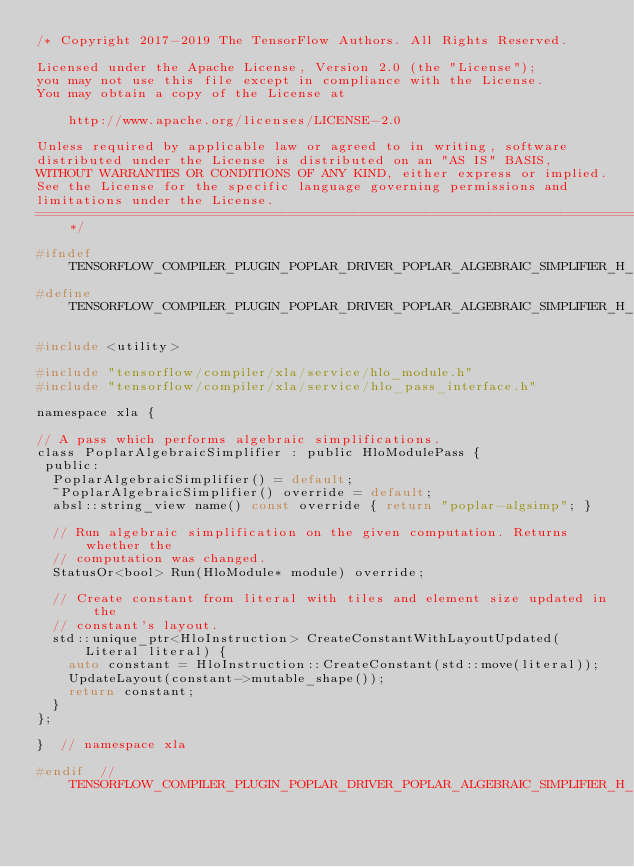<code> <loc_0><loc_0><loc_500><loc_500><_C_>/* Copyright 2017-2019 The TensorFlow Authors. All Rights Reserved.

Licensed under the Apache License, Version 2.0 (the "License");
you may not use this file except in compliance with the License.
You may obtain a copy of the License at

    http://www.apache.org/licenses/LICENSE-2.0

Unless required by applicable law or agreed to in writing, software
distributed under the License is distributed on an "AS IS" BASIS,
WITHOUT WARRANTIES OR CONDITIONS OF ANY KIND, either express or implied.
See the License for the specific language governing permissions and
limitations under the License.
==============================================================================*/

#ifndef TENSORFLOW_COMPILER_PLUGIN_POPLAR_DRIVER_POPLAR_ALGEBRAIC_SIMPLIFIER_H_
#define TENSORFLOW_COMPILER_PLUGIN_POPLAR_DRIVER_POPLAR_ALGEBRAIC_SIMPLIFIER_H_

#include <utility>

#include "tensorflow/compiler/xla/service/hlo_module.h"
#include "tensorflow/compiler/xla/service/hlo_pass_interface.h"

namespace xla {

// A pass which performs algebraic simplifications.
class PoplarAlgebraicSimplifier : public HloModulePass {
 public:
  PoplarAlgebraicSimplifier() = default;
  ~PoplarAlgebraicSimplifier() override = default;
  absl::string_view name() const override { return "poplar-algsimp"; }

  // Run algebraic simplification on the given computation. Returns whether the
  // computation was changed.
  StatusOr<bool> Run(HloModule* module) override;

  // Create constant from literal with tiles and element size updated in the
  // constant's layout.
  std::unique_ptr<HloInstruction> CreateConstantWithLayoutUpdated(
      Literal literal) {
    auto constant = HloInstruction::CreateConstant(std::move(literal));
    UpdateLayout(constant->mutable_shape());
    return constant;
  }
};

}  // namespace xla

#endif  // TENSORFLOW_COMPILER_PLUGIN_POPLAR_DRIVER_POPLAR_ALGEBRAIC_SIMPLIFIER_H_
</code> 